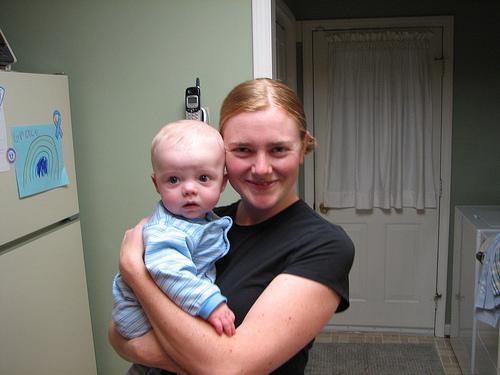How many people are in the photo?
Give a very brief answer. 2. 